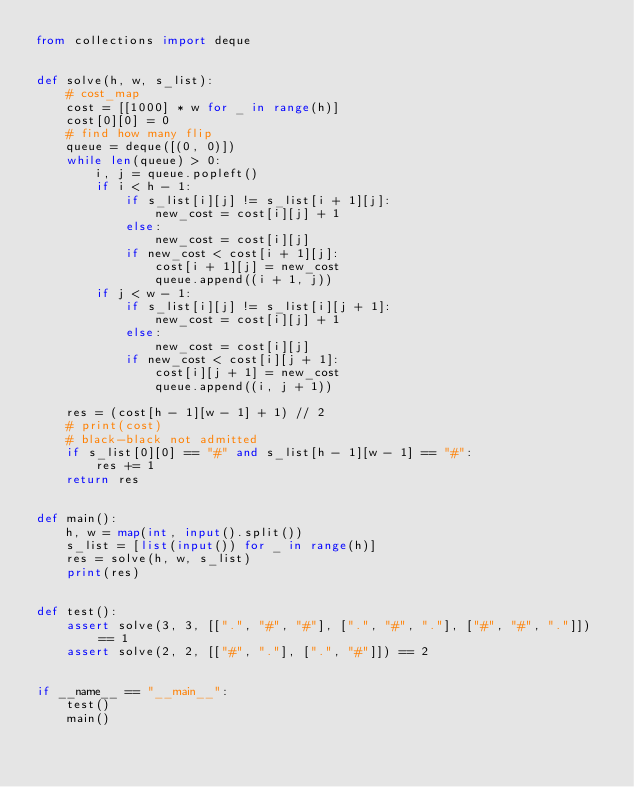Convert code to text. <code><loc_0><loc_0><loc_500><loc_500><_Python_>from collections import deque


def solve(h, w, s_list):
    # cost_map
    cost = [[1000] * w for _ in range(h)]
    cost[0][0] = 0
    # find how many flip
    queue = deque([(0, 0)])
    while len(queue) > 0:
        i, j = queue.popleft()
        if i < h - 1:
            if s_list[i][j] != s_list[i + 1][j]:
                new_cost = cost[i][j] + 1
            else:
                new_cost = cost[i][j]
            if new_cost < cost[i + 1][j]:
                cost[i + 1][j] = new_cost
                queue.append((i + 1, j))
        if j < w - 1:
            if s_list[i][j] != s_list[i][j + 1]:
                new_cost = cost[i][j] + 1
            else:
                new_cost = cost[i][j]
            if new_cost < cost[i][j + 1]:
                cost[i][j + 1] = new_cost
                queue.append((i, j + 1))

    res = (cost[h - 1][w - 1] + 1) // 2
    # print(cost)
    # black-black not admitted
    if s_list[0][0] == "#" and s_list[h - 1][w - 1] == "#":
        res += 1
    return res


def main():
    h, w = map(int, input().split())
    s_list = [list(input()) for _ in range(h)]
    res = solve(h, w, s_list)
    print(res)


def test():
    assert solve(3, 3, [[".", "#", "#"], [".", "#", "."], ["#", "#", "."]]) == 1
    assert solve(2, 2, [["#", "."], [".", "#"]]) == 2


if __name__ == "__main__":
    test()
    main()
</code> 